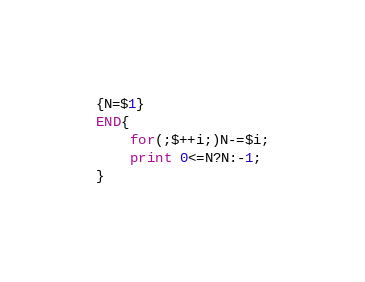<code> <loc_0><loc_0><loc_500><loc_500><_Awk_>{N=$1}
END{
    for(;$++i;)N-=$i;
    print 0<=N?N:-1;
}</code> 